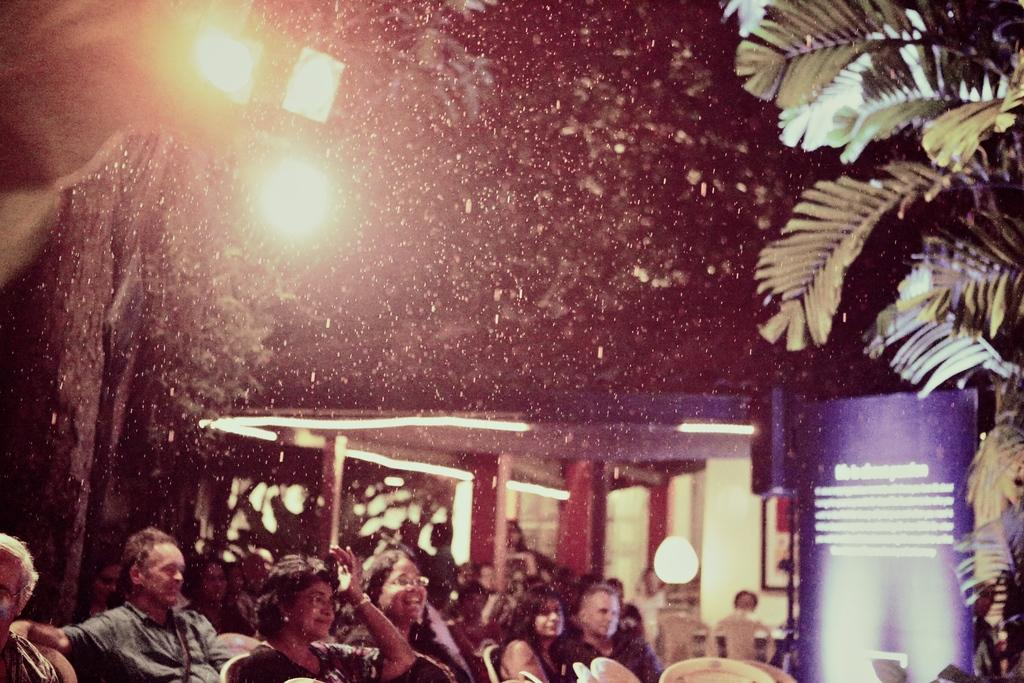What is the person in the image doing? The person is sitting on a chair at the bottom of the image. What can be seen on the right side of the image? There is a tree at the right side of the image. What is visible on the left side of the image? There is a tree trunk at the left side of the image. What type of boot is hanging from the tree in the image? There is no boot hanging from the tree in the image; only a tree and a tree trunk are visible. 